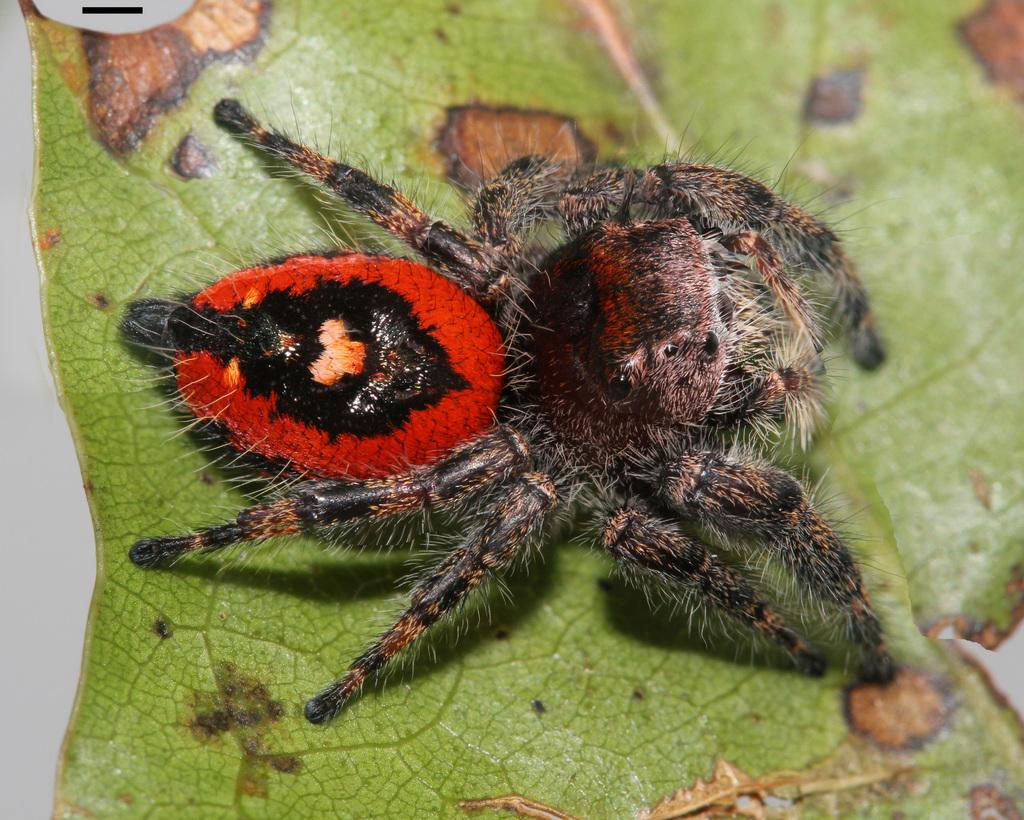What type of creature is in the image? There is an insect in the image. What colors can be seen on the insect? The insect has black and red colors. Where is the insect located in the image? The insect is on a leaf. What is the color of the background in the image? The background of the image is white in color. What advice does the insect give to the celery in the image? There is no celery present in the image, and insects do not give advice. 